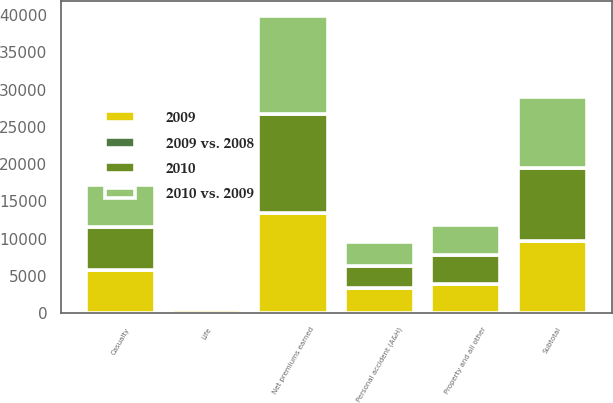<chart> <loc_0><loc_0><loc_500><loc_500><stacked_bar_chart><ecel><fcel>Property and all other<fcel>Casualty<fcel>Subtotal<fcel>Personal accident (A&H)<fcel>Life<fcel>Net premiums earned<nl><fcel>2009<fcel>3898<fcel>5752<fcel>9650<fcel>3331<fcel>523<fcel>13504<nl><fcel>2010 vs. 2009<fcel>4023<fcel>5587<fcel>9610<fcel>3198<fcel>432<fcel>13240<nl><fcel>2010<fcel>3954<fcel>5838<fcel>9792<fcel>3004<fcel>407<fcel>13203<nl><fcel>2009 vs. 2008<fcel>3<fcel>3<fcel>0<fcel>4<fcel>21<fcel>2<nl></chart> 